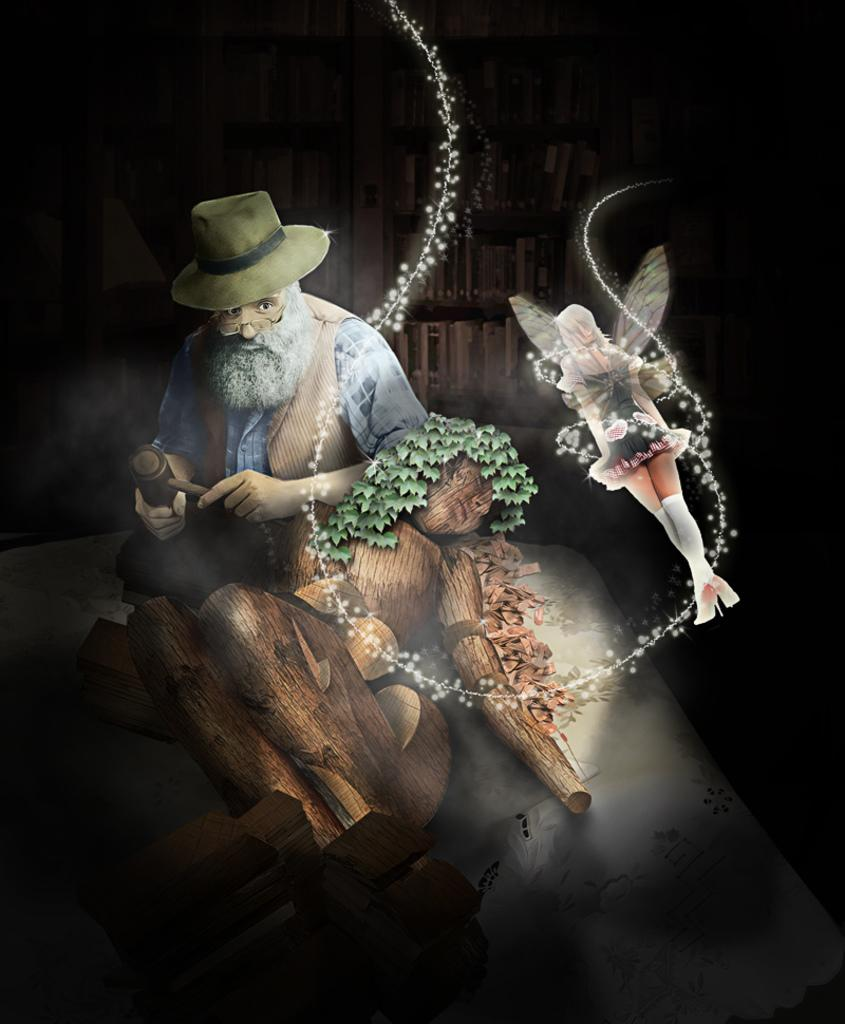What type of image is this? The image is animated. Can you describe the person in the image? There is a person wearing spectacles in the image. What is the person holding in the image? The person is holding an object. What type of objects can be seen in the image? There are wooden objects in the image. Where are these objects located? There are shelves with objects in the image. What type of fang can be seen in the image? There is no fang present in the image. Is the person in the image using a plough? There is no plough present in the image. 